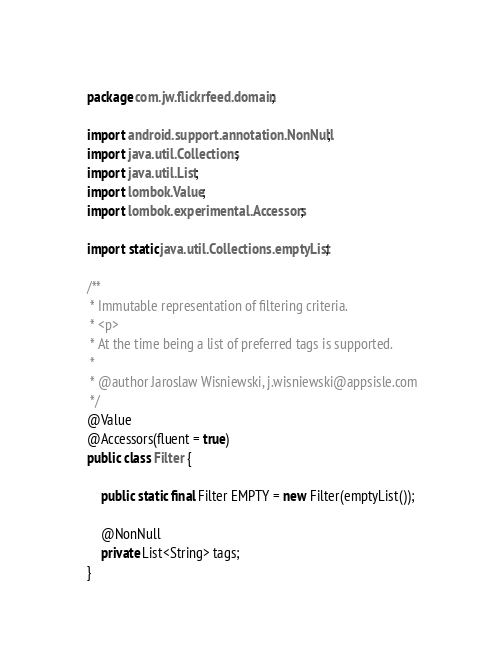<code> <loc_0><loc_0><loc_500><loc_500><_Java_>package com.jw.flickrfeed.domain;

import android.support.annotation.NonNull;
import java.util.Collections;
import java.util.List;
import lombok.Value;
import lombok.experimental.Accessors;

import static java.util.Collections.emptyList;

/**
 * Immutable representation of filtering criteria.
 * <p>
 * At the time being a list of preferred tags is supported.
 *
 * @author Jaroslaw Wisniewski, j.wisniewski@appsisle.com
 */
@Value
@Accessors(fluent = true)
public class Filter {

    public static final Filter EMPTY = new Filter(emptyList());

    @NonNull
    private List<String> tags;
}
</code> 